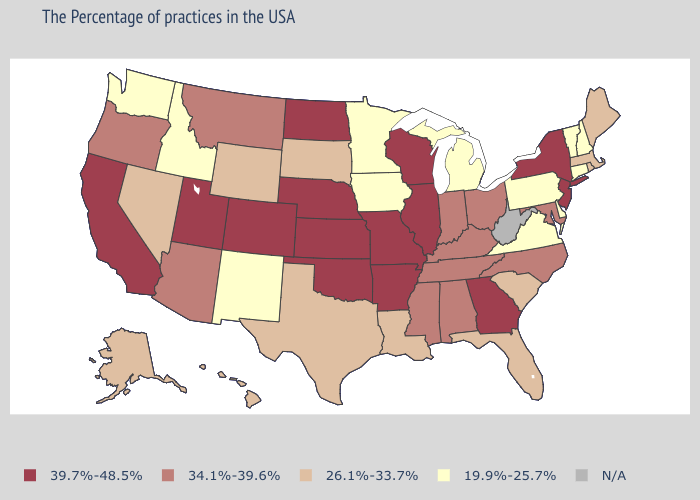What is the value of Minnesota?
Keep it brief. 19.9%-25.7%. Name the states that have a value in the range 39.7%-48.5%?
Concise answer only. New York, New Jersey, Georgia, Wisconsin, Illinois, Missouri, Arkansas, Kansas, Nebraska, Oklahoma, North Dakota, Colorado, Utah, California. What is the value of New York?
Short answer required. 39.7%-48.5%. What is the highest value in the USA?
Write a very short answer. 39.7%-48.5%. How many symbols are there in the legend?
Concise answer only. 5. Does California have the highest value in the USA?
Write a very short answer. Yes. Does the first symbol in the legend represent the smallest category?
Be succinct. No. Does Wisconsin have the highest value in the MidWest?
Give a very brief answer. Yes. What is the highest value in the USA?
Quick response, please. 39.7%-48.5%. Name the states that have a value in the range 19.9%-25.7%?
Short answer required. New Hampshire, Vermont, Connecticut, Delaware, Pennsylvania, Virginia, Michigan, Minnesota, Iowa, New Mexico, Idaho, Washington. Which states have the lowest value in the South?
Answer briefly. Delaware, Virginia. What is the value of Nebraska?
Be succinct. 39.7%-48.5%. Among the states that border Virginia , which have the lowest value?
Be succinct. Maryland, North Carolina, Kentucky, Tennessee. 